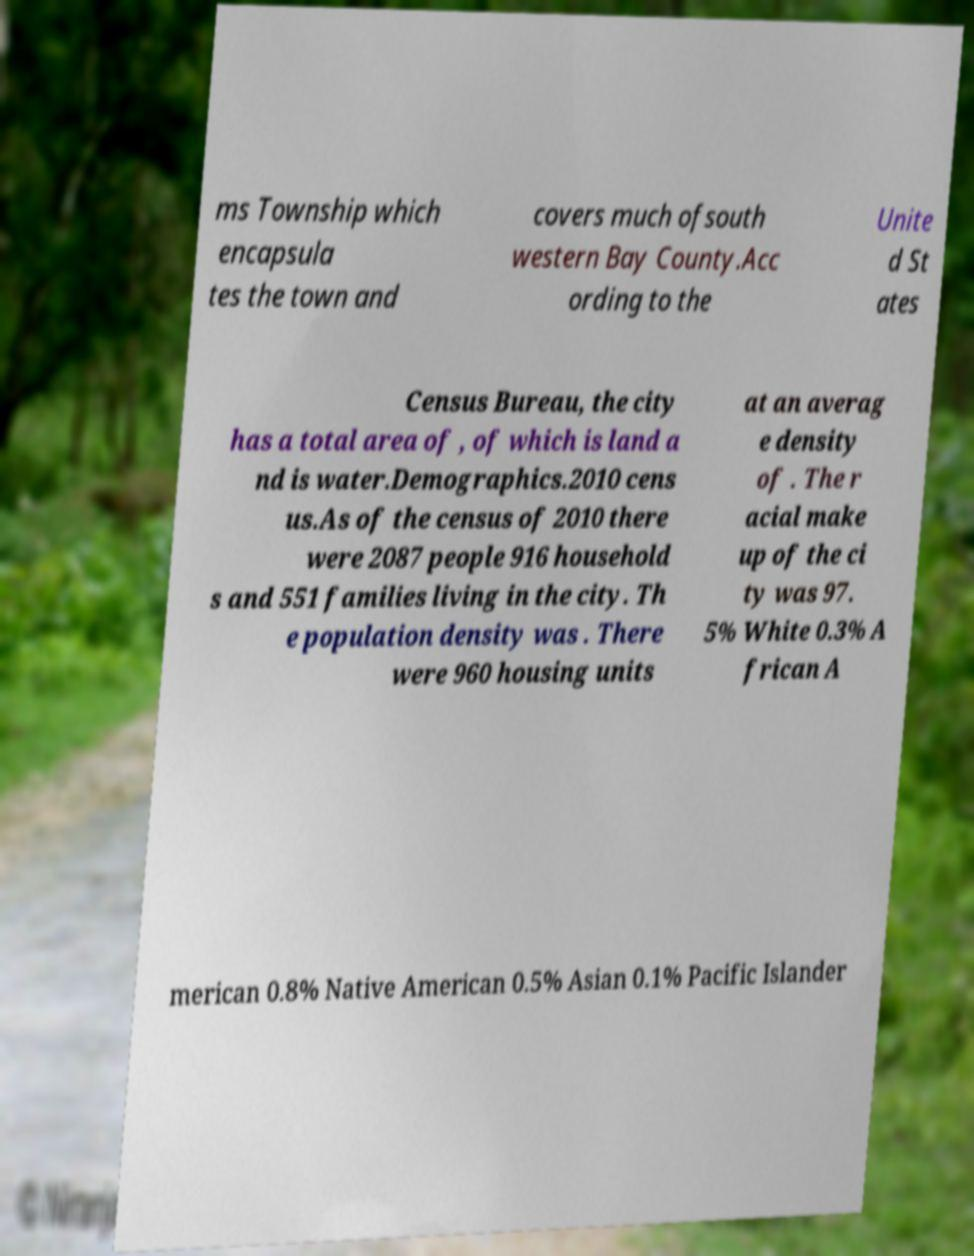I need the written content from this picture converted into text. Can you do that? ms Township which encapsula tes the town and covers much ofsouth western Bay County.Acc ording to the Unite d St ates Census Bureau, the city has a total area of , of which is land a nd is water.Demographics.2010 cens us.As of the census of 2010 there were 2087 people 916 household s and 551 families living in the city. Th e population density was . There were 960 housing units at an averag e density of . The r acial make up of the ci ty was 97. 5% White 0.3% A frican A merican 0.8% Native American 0.5% Asian 0.1% Pacific Islander 